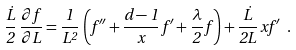<formula> <loc_0><loc_0><loc_500><loc_500>\frac { \dot { L } } { 2 } \, \frac { \partial f } { \partial L } = \frac { 1 } { L ^ { 2 } } \, \left ( f ^ { \prime \prime } + \frac { d - 1 } { x } \, f ^ { \prime } + \frac { \lambda } { 2 } \, f \right ) + \frac { \dot { L } } { 2 L } \, x f ^ { \prime } \ .</formula> 